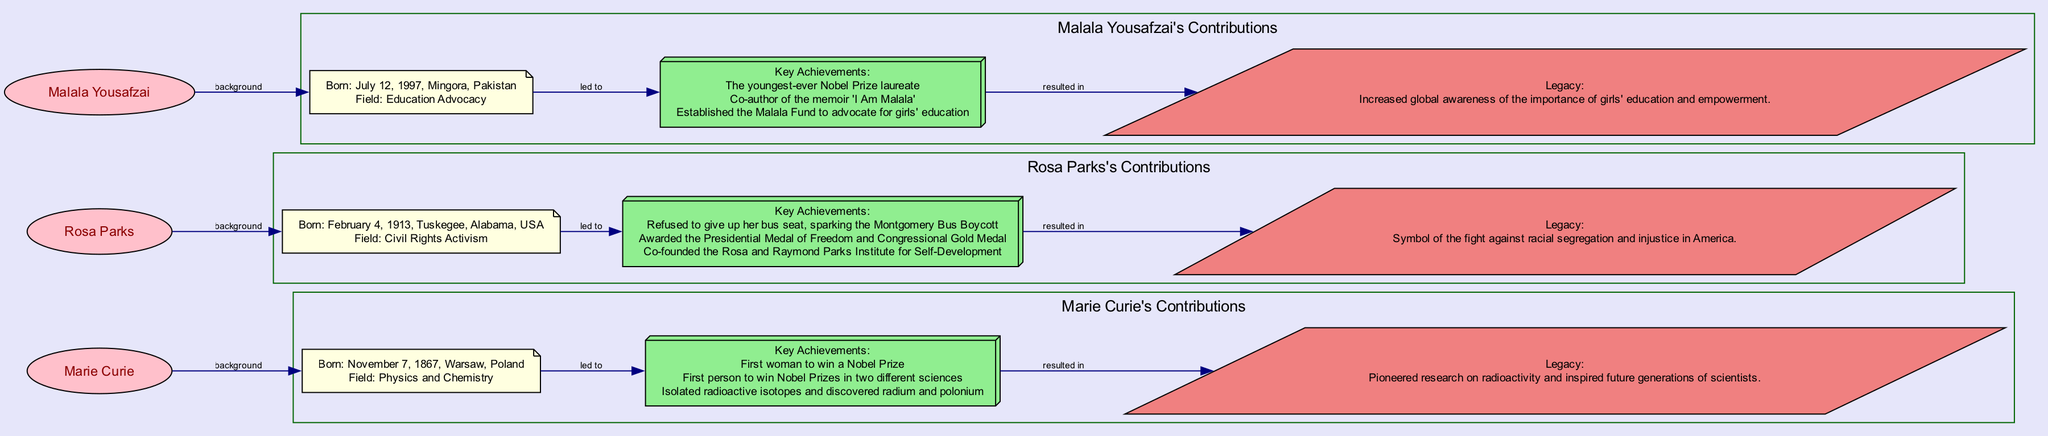What is the birth date of Marie Curie? The diagram states Marie Curie's birth date as November 7, 1867.
Answer: November 7, 1867 What major field did Rosa Parks contribute to? According to the diagram, Rosa Parks is identified as contributing to Civil Rights Activism.
Answer: Civil Rights Activism How many key achievements are listed for Malala Yousafzai? The diagram contains three key achievements listed under Malala Yousafzai's contributions.
Answer: 3 Which woman is noted for co-authoring the memoir 'I Am Malala'? The diagram shows that Malala Yousafzai is associated with the memoir 'I Am Malala'.
Answer: Malala Yousafzai What legacy is associated with Rosa Parks? The legacy stated in the diagram is that Rosa Parks is a symbol of the fight against racial segregation and injustice in America.
Answer: Symbol of the fight against racial segregation and injustice in America Who was the first woman to win a Nobel Prize? The diagram indicates that Marie Curie was the first woman to win a Nobel Prize.
Answer: Marie Curie What connects the background of each woman to their key achievements? The diagram illustrates that the background node for each woman leads to their key achievements, indicating a direct relationship between their origins and what they accomplished.
Answer: Background leads to key achievements Which woman’s efforts led to increased global awareness of girls' education? The diagram clearly shows that Malala Yousafzai's efforts resulted in increased global awareness regarding the importance of girls' education.
Answer: Malala Yousafzai What type of shape is used to represent the legacy of each woman? The diagram uses a parallelogram shape to represent the legacy of each woman.
Answer: Parallelogram 